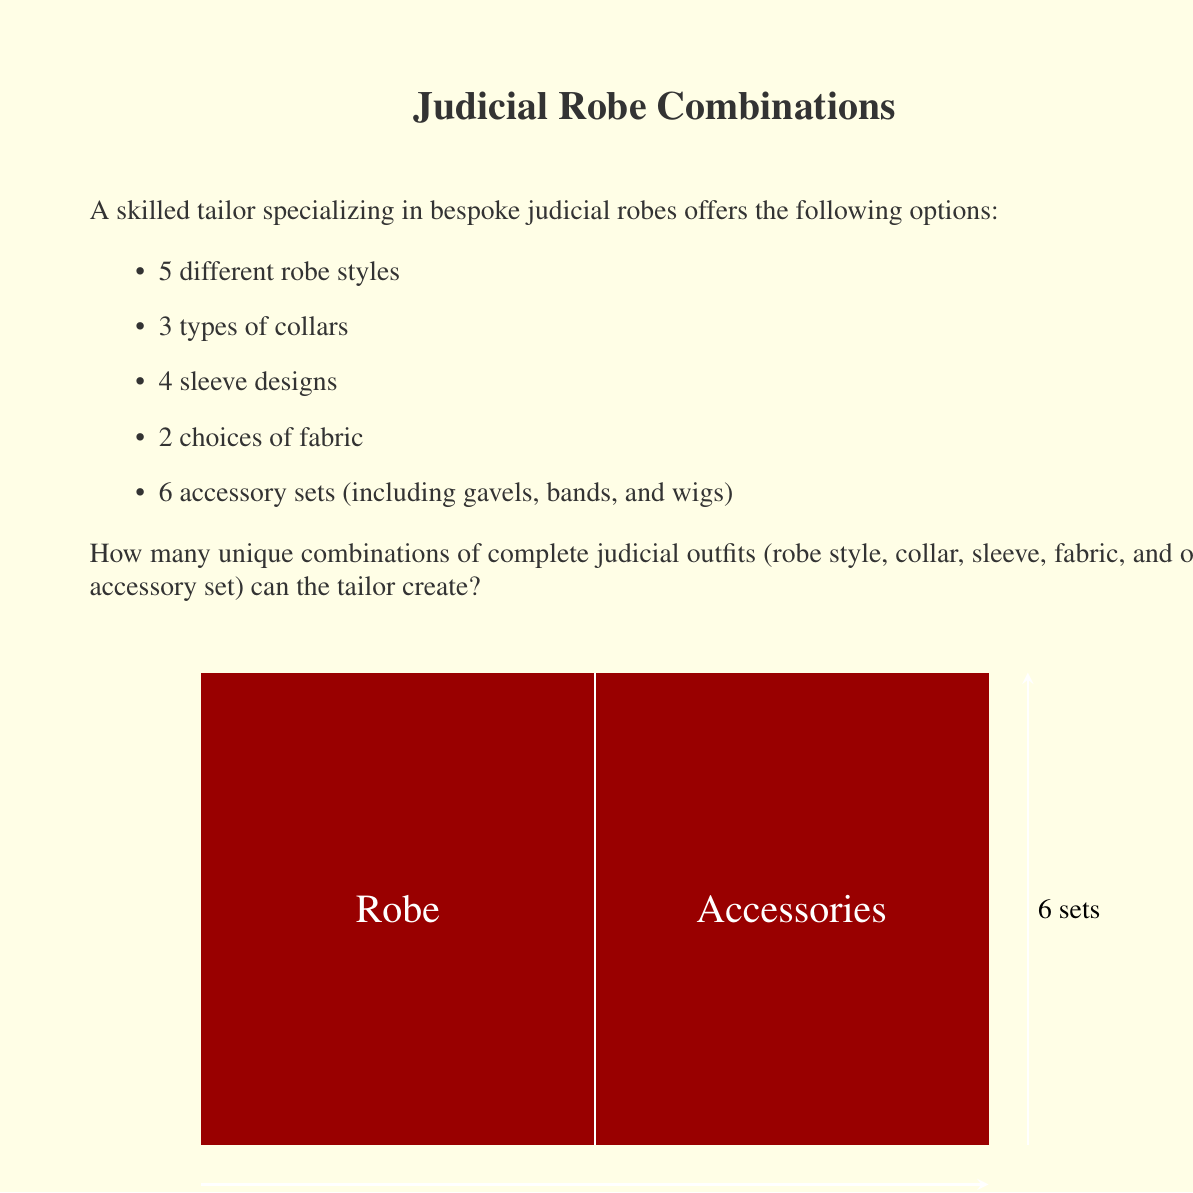Show me your answer to this math problem. To solve this problem, we'll use the multiplication principle of counting. This principle states that if we have a sequence of independent choices, the total number of possible outcomes is the product of the number of possibilities for each choice.

Let's break down the choices:

1. Robe style: 5 options
2. Collar type: 3 options
3. Sleeve design: 4 options
4. Fabric choice: 2 options
5. Accessory set: 6 options

For each complete judicial outfit, the tailor needs to make one choice from each category. These choices are independent of each other, meaning the choice in one category doesn't affect the choices available in other categories.

Therefore, we multiply the number of options for each choice:

$$ \text{Total combinations} = 5 \times 3 \times 4 \times 2 \times 6 $$

Calculating this:

$$ \begin{align}
\text{Total combinations} &= 5 \times 3 \times 4 \times 2 \times 6 \\
&= 60 \times 4 \times 2 \times 6 \\
&= 240 \times 6 \\
&= 1440
\end{align} $$

Thus, the tailor can create 1440 unique combinations of complete judicial outfits.
Answer: 1440 unique combinations 